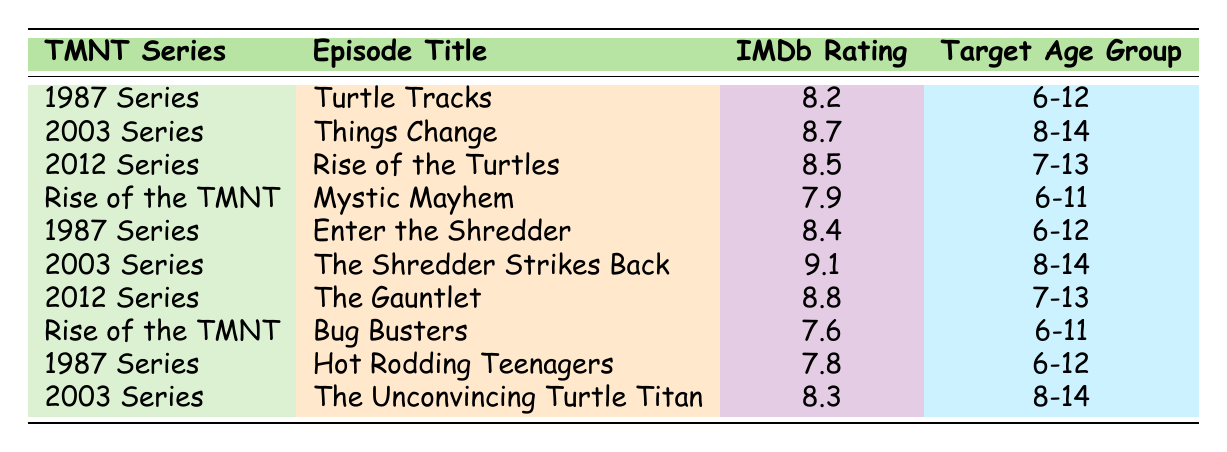What is the highest IMDb rating among the episodes listed? The table shows multiple episodes with their respective IMDb ratings. The highest rating can be found by comparing all the values in the IMDb Rating column, which are 8.2, 8.7, 8.5, 7.9, 8.4, 9.1, 8.8, 7.6, 7.8, and 8.3. Among these, 9.1 is the highest.
Answer: 9.1 Which TMNT series has the episode titled "The Gauntlet"? By looking at the Episode Title column, I can find that "The Gauntlet" is listed under the 2012 Series.
Answer: 2012 Series Is "Rise of the Turtles" aimed at an age group higher than 7-13? The target age group for "Rise of the Turtles" is listed as 7-13, which means it is not higher than this age range since 7-13 is the specified range.
Answer: No What is the average IMDb rating of the episodes in the 1987 Series? The episodes listed under the 1987 Series have ratings of 8.2, 8.4, 7.8. To find the average, sum these ratings: 8.2 + 8.4 + 7.8 = 24.4. There are 3 episodes, so the average is 24.4 / 3 = 8.13.
Answer: 8.13 How many episodes in the table target an age group of 6-12? By examining the Target Age Group column, the episodes aimed at 6-12 are: "Turtle Tracks", "Enter the Shredder", and "Hot Rodding Teenagers". That makes 3 episodes targeting this age group.
Answer: 3 Which series has the lowest rated episode in the table? The lowest IMDb rating is 7.6, which belongs to the episode "Bug Busters" in the Rise of the TMNT series. After checking all the ratings, I can determine which one is the lowest.
Answer: Rise of the TMNT Do all episodes from the 2003 Series have higher ratings than 8.0? The ratings for the 2003 Series episodes are 8.7, 9.1, and 8.3. Since all these ratings are above 8.0, the answer is yes.
Answer: Yes What is the difference in IMDb ratings between "Things Change" and "Bug Busters"? The IMDb rating for "Things Change" is 8.7, while "Bug Busters" has a rating of 7.6. To find the difference, subtract the lower rating from the higher one: 8.7 - 7.6 = 1.1.
Answer: 1.1 